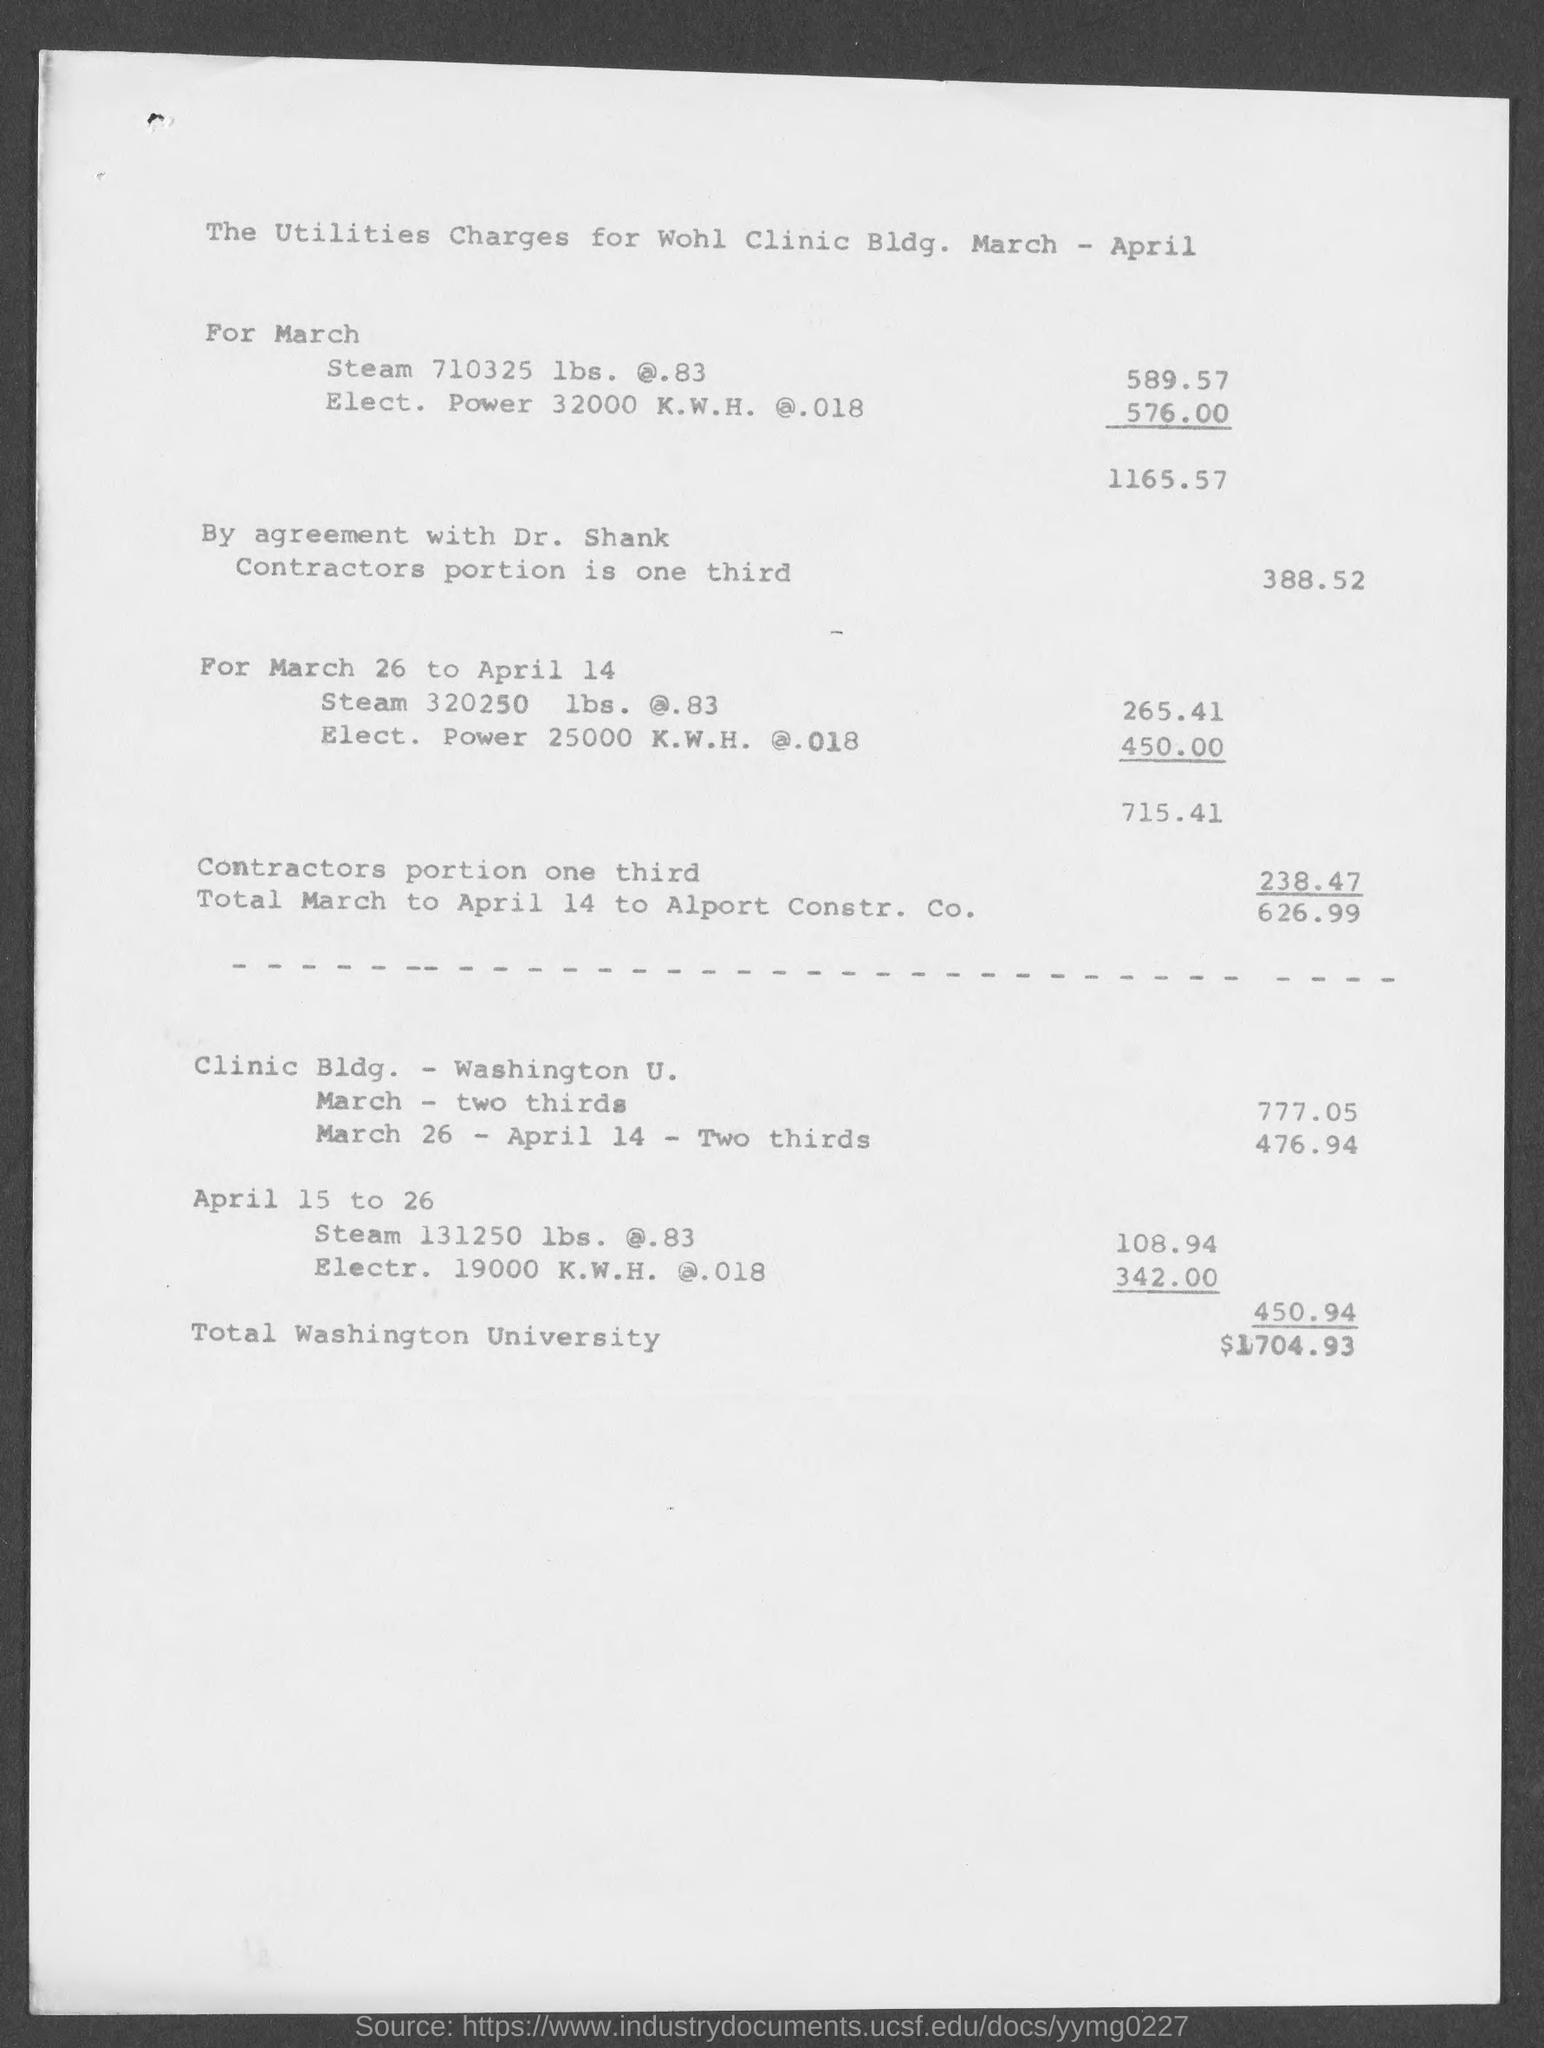Utilities charges for which month is shown ?
Your answer should be very brief. March- April. How much is the cost of  "Steam 320250 lbs. @.83" for March 26 to April 14?
Your answer should be very brief. 265.41. How much is the cost of  "Elect. Power 25000 K.W.H @.018" for March 26 to April 14?
Provide a short and direct response. 450.00. How much is the total cost for March 26 to April 14 ?
Your answer should be very brief. 715.41. How much is the cost of  "Steam 131250 lbs. @.83" for April 15 to 26 ?
Give a very brief answer. 108.94. How much is the cost of  "Electr. 19000 K.W.H. @.018" for April 15 to 26 ?
Give a very brief answer. 342.00. How much is the total cost for Washington university ?
Offer a very short reply. $1704.93. 